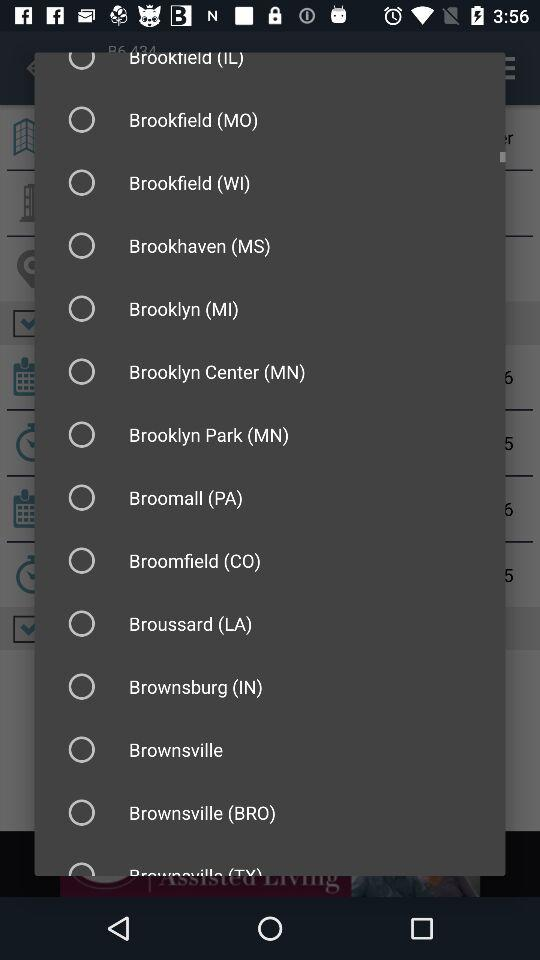Which date is selected? The selected date is Friday, December 12, 2016. 